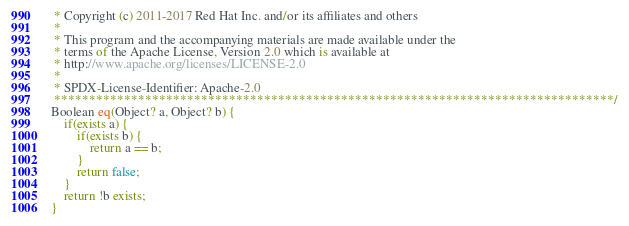Convert code to text. <code><loc_0><loc_0><loc_500><loc_500><_Ceylon_> * Copyright (c) 2011-2017 Red Hat Inc. and/or its affiliates and others
 *
 * This program and the accompanying materials are made available under the 
 * terms of the Apache License, Version 2.0 which is available at
 * http://www.apache.org/licenses/LICENSE-2.0
 *
 * SPDX-License-Identifier: Apache-2.0 
 ********************************************************************************/
Boolean eq(Object? a, Object? b) {
    if(exists a) {
        if(exists b) {
            return a == b;
        }
        return false;
    }
    return !b exists;
}
</code> 